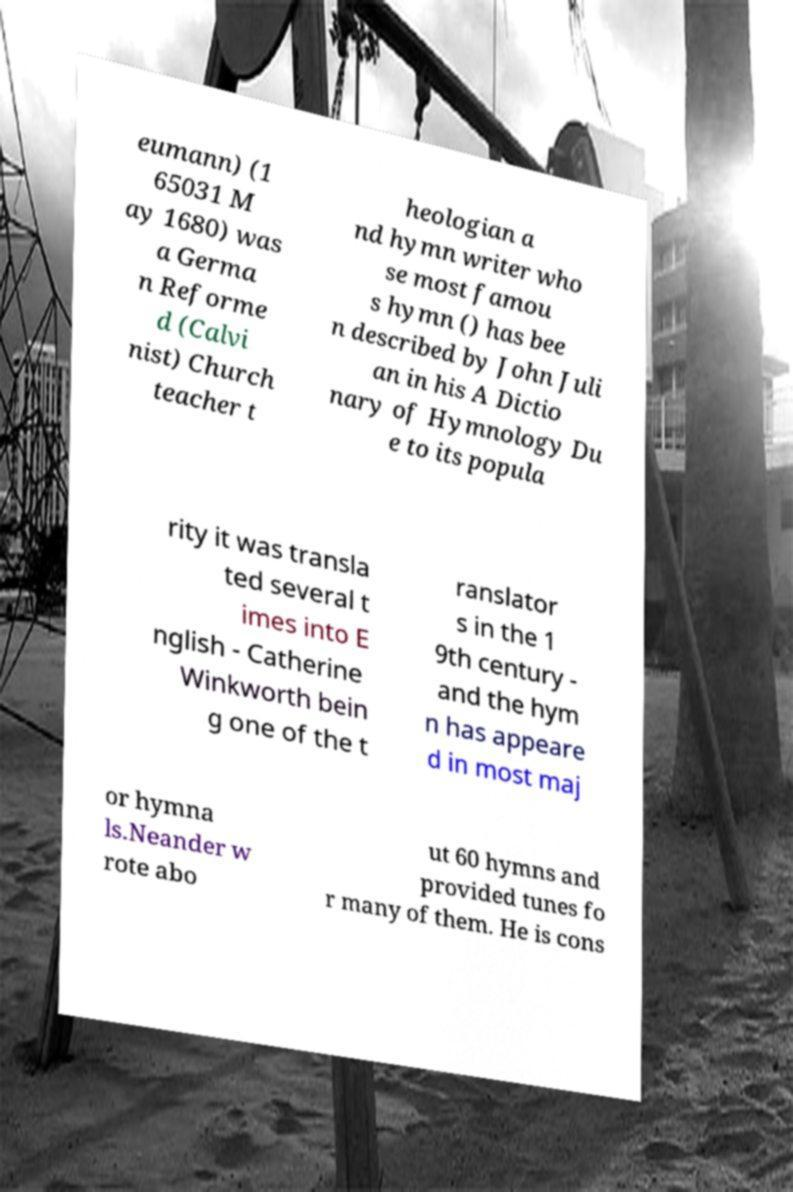I need the written content from this picture converted into text. Can you do that? eumann) (1 65031 M ay 1680) was a Germa n Reforme d (Calvi nist) Church teacher t heologian a nd hymn writer who se most famou s hymn () has bee n described by John Juli an in his A Dictio nary of Hymnology Du e to its popula rity it was transla ted several t imes into E nglish - Catherine Winkworth bein g one of the t ranslator s in the 1 9th century - and the hym n has appeare d in most maj or hymna ls.Neander w rote abo ut 60 hymns and provided tunes fo r many of them. He is cons 